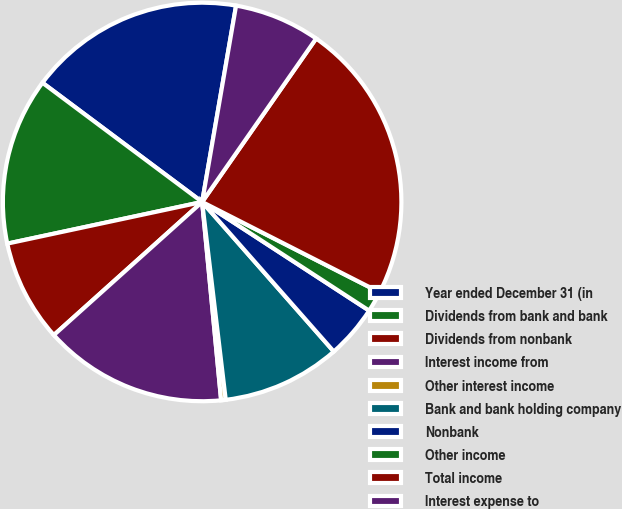Convert chart. <chart><loc_0><loc_0><loc_500><loc_500><pie_chart><fcel>Year ended December 31 (in<fcel>Dividends from bank and bank<fcel>Dividends from nonbank<fcel>Interest income from<fcel>Other interest income<fcel>Bank and bank holding company<fcel>Nonbank<fcel>Other income<fcel>Total income<fcel>Interest expense to<nl><fcel>17.52%<fcel>13.56%<fcel>8.29%<fcel>14.88%<fcel>0.37%<fcel>9.6%<fcel>4.33%<fcel>1.69%<fcel>22.8%<fcel>6.97%<nl></chart> 